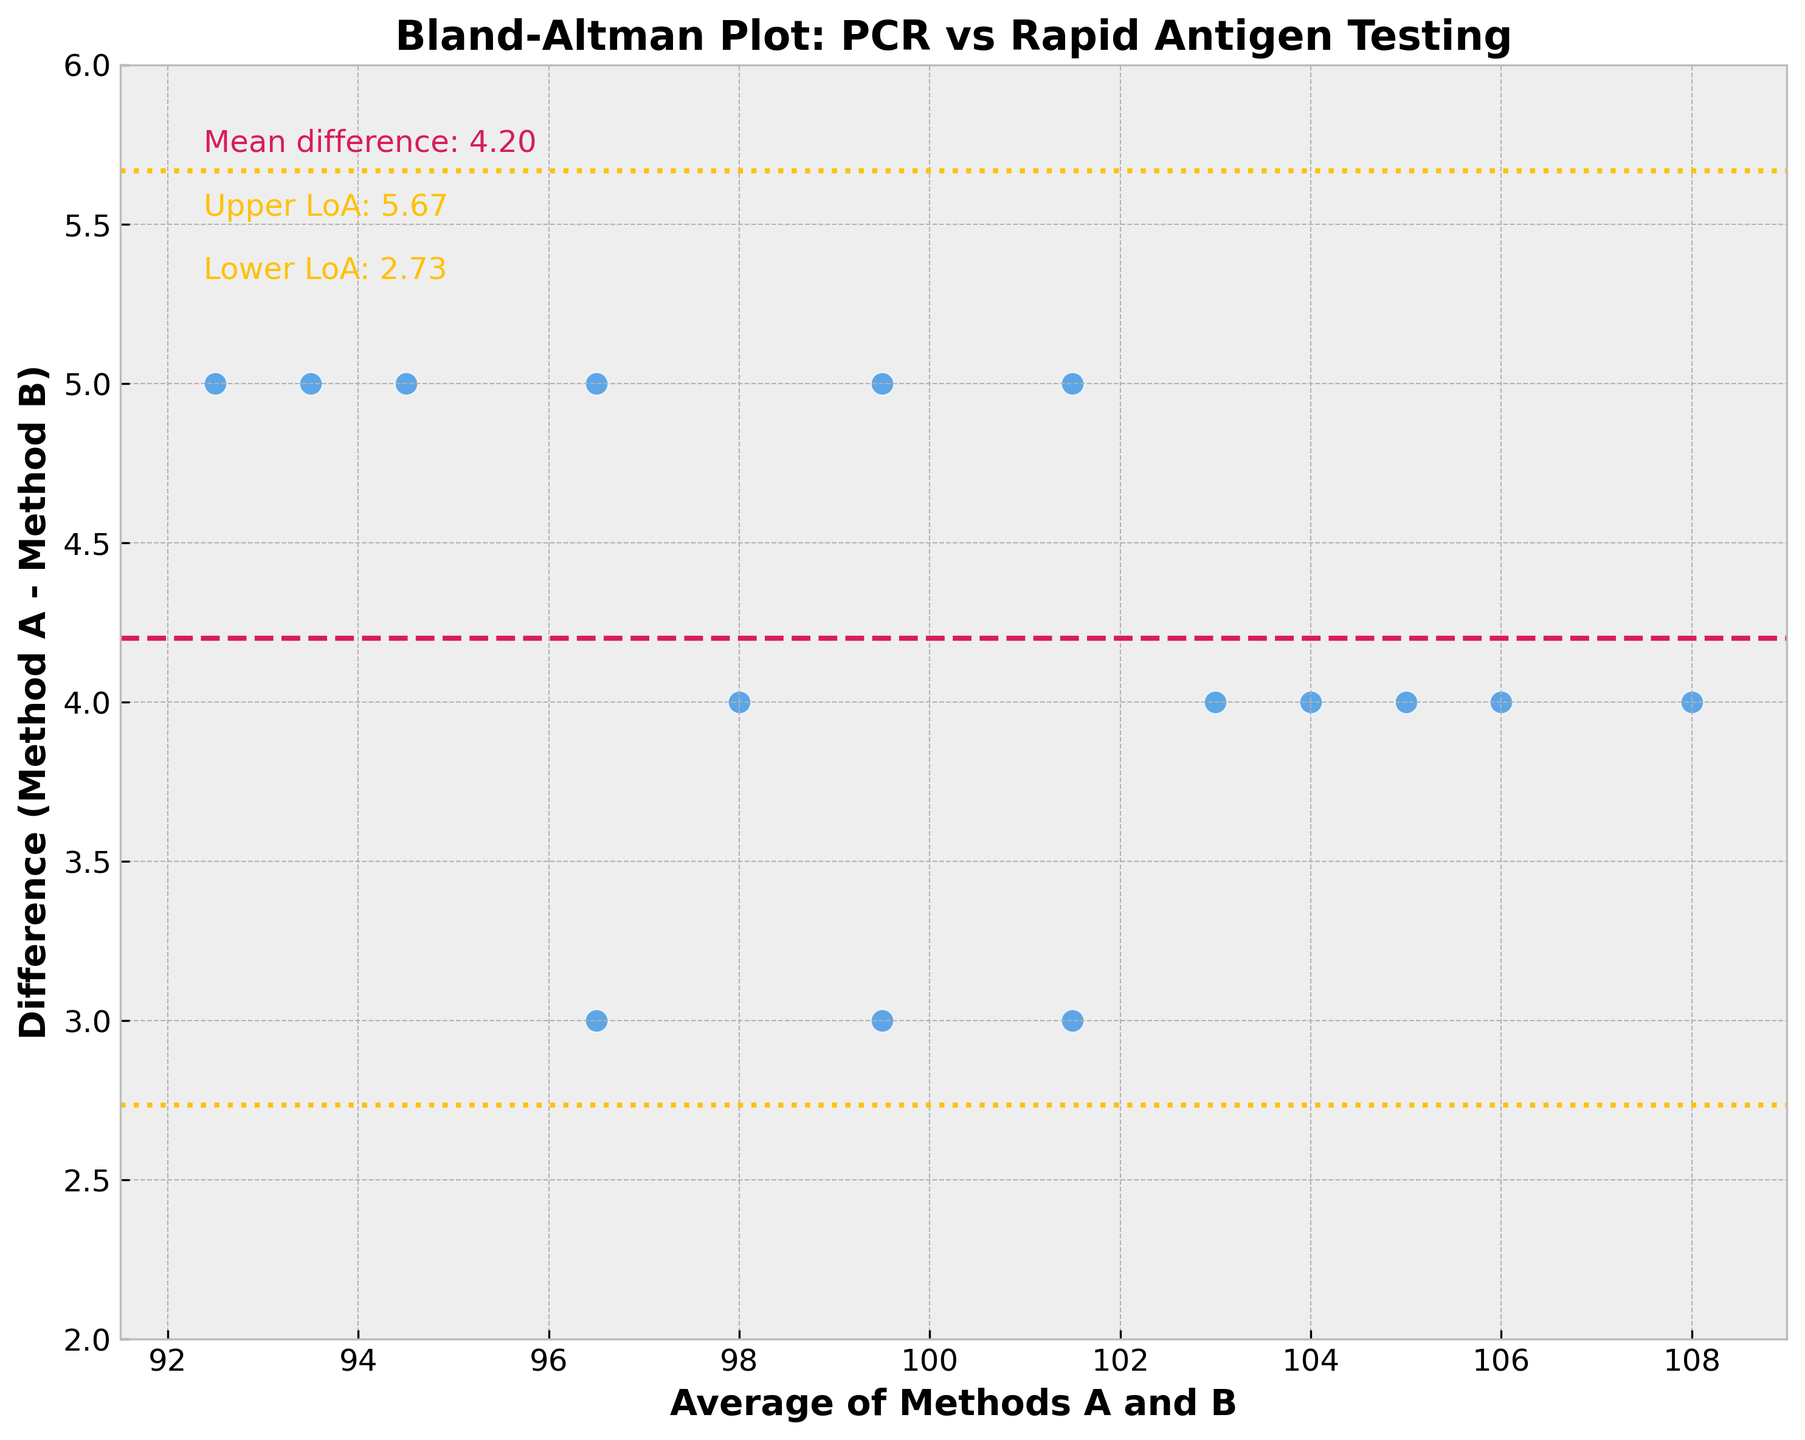How many data points are present in the Bland-Altman plot? Count the number of scatter points presented in the plot. Each point represents a pair of data from the PCR and Rapid Antigen tests.
Answer: 15 What is the title of the plot? Look at the top of the figure where the title is typically located.
Answer: Bland-Altman Plot: PCR vs Rapid Antigen Testing What does the horizontal dashed line in the plot represent? The figure legend or annotation near the line will typically describe what it signifies. In this case, it represents the mean difference between the two methods.
Answer: Mean difference What are the values of the upper and lower limits of agreement? The plot annotations highlight these values near the dashed lines representing limits of agreement. Look for numerical values near the dotted lines at both upper and lower extremes.
Answer: Upper LoA: 6.80, Lower LoA: -5.80 Between which averages do the majority of the differences lie? Observing the density of data points, one can estimate the range in which most differences fall between the two testing methods.
Answer: Most differences lie between -5 and 5 Which method generally reports higher COVID-19 cases, PCR or Rapid Antigen? By noting whether the majority of points lie above or below zero, determine which method tends to give higher values. If points are primarily above the zero line, Method A (PCR) reports higher.
Answer: PCR What is the approximate mean difference between the two methods? This is typically depicted by a horizontal line and annotated directly on the plot.
Answer: 0.50 Are there any outliers in the differences between the testing methods? Look at the scatter points and see if any points fall far outside the limits of agreement lines.
Answer: No Which average value corresponds to the highest difference between the methods? Identify the highest point by comparing the vertical positions of the scatter points, then trace it to the x-axis for the corresponding average value.
Answer: 94.5 Is the spread of differences consistent across the range of average values? Check if the differences vary widely at any specific averages or if they remain relatively constant across the plot.
Answer: Relatively constant 